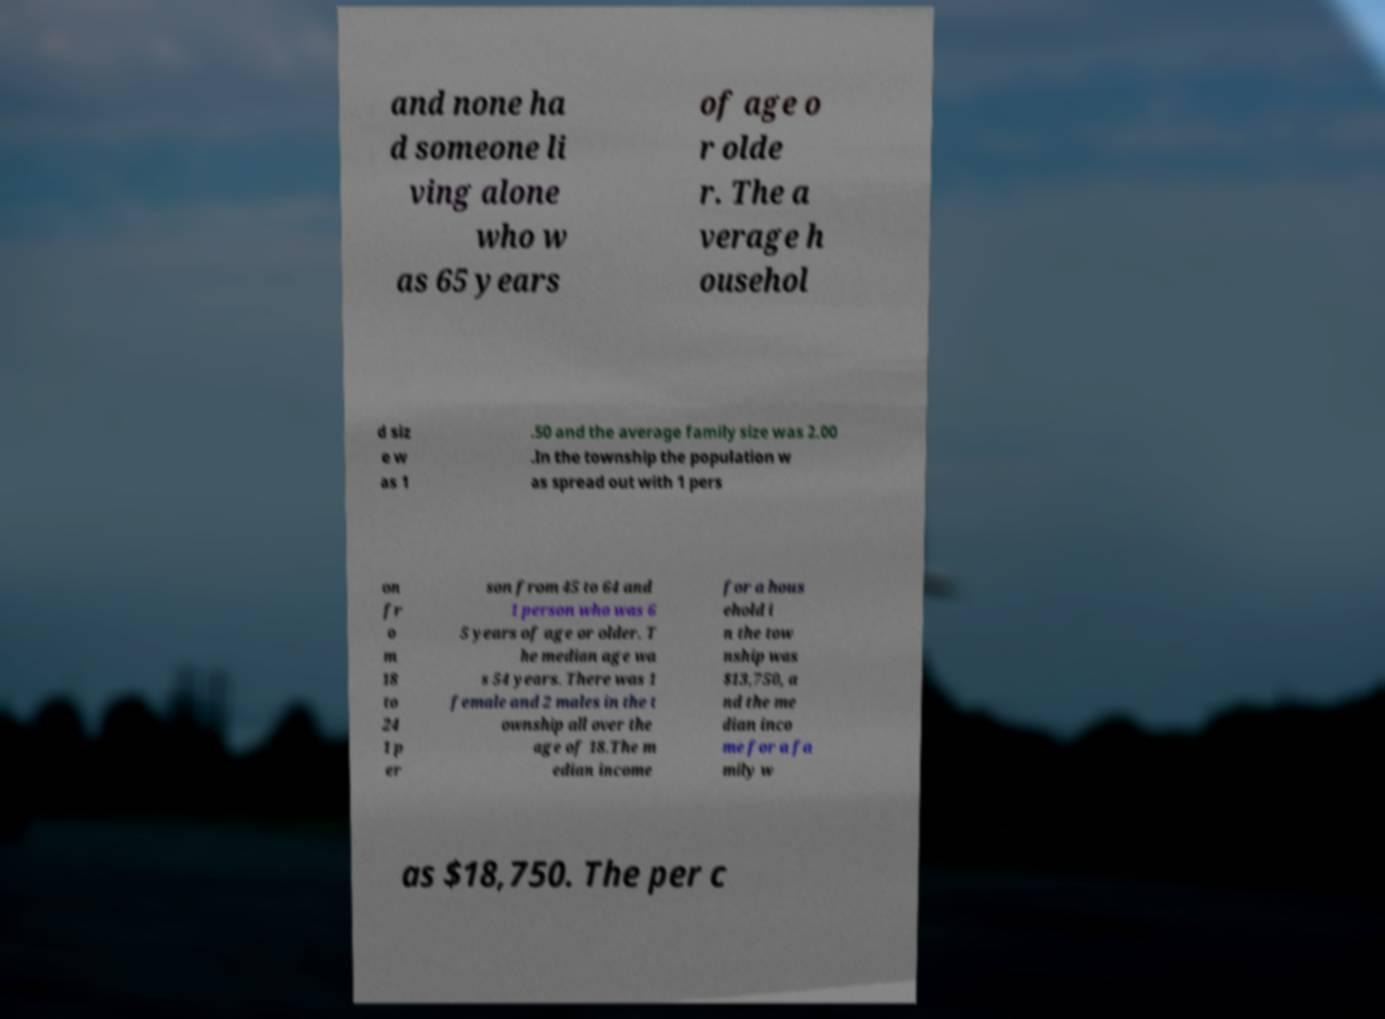Could you assist in decoding the text presented in this image and type it out clearly? and none ha d someone li ving alone who w as 65 years of age o r olde r. The a verage h ousehol d siz e w as 1 .50 and the average family size was 2.00 .In the township the population w as spread out with 1 pers on fr o m 18 to 24 1 p er son from 45 to 64 and 1 person who was 6 5 years of age or older. T he median age wa s 54 years. There was 1 female and 2 males in the t ownship all over the age of 18.The m edian income for a hous ehold i n the tow nship was $13,750, a nd the me dian inco me for a fa mily w as $18,750. The per c 